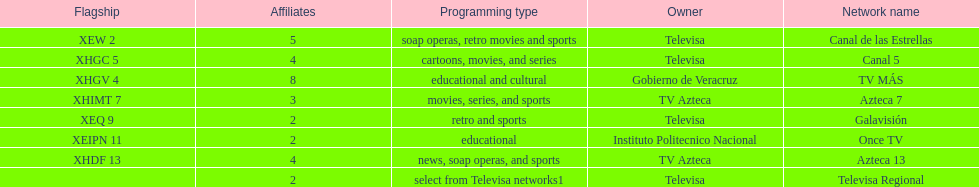Could you parse the entire table as a dict? {'header': ['Flagship', 'Affiliates', 'Programming type', 'Owner', 'Network name'], 'rows': [['XEW 2', '5', 'soap operas, retro movies and sports', 'Televisa', 'Canal de las Estrellas'], ['XHGC 5', '4', 'cartoons, movies, and series', 'Televisa', 'Canal 5'], ['XHGV 4', '8', 'educational and cultural', 'Gobierno de Veracruz', 'TV MÁS'], ['XHIMT 7', '3', 'movies, series, and sports', 'TV Azteca', 'Azteca 7'], ['XEQ 9', '2', 'retro and sports', 'Televisa', 'Galavisión'], ['XEIPN 11', '2', 'educational', 'Instituto Politecnico Nacional', 'Once TV'], ['XHDF 13', '4', 'news, soap operas, and sports', 'TV Azteca', 'Azteca 13'], ['', '2', 'select from Televisa networks1', 'Televisa', 'Televisa Regional']]} How many networks show soap operas? 2. 